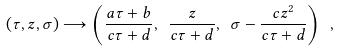<formula> <loc_0><loc_0><loc_500><loc_500>( \tau , z , \sigma ) \longrightarrow \left ( \frac { a \tau + b } { c \tau + d } , \ \frac { z } { c \tau + d } , \ \sigma - \frac { c z ^ { 2 } } { c \tau + d } \right ) \ ,</formula> 